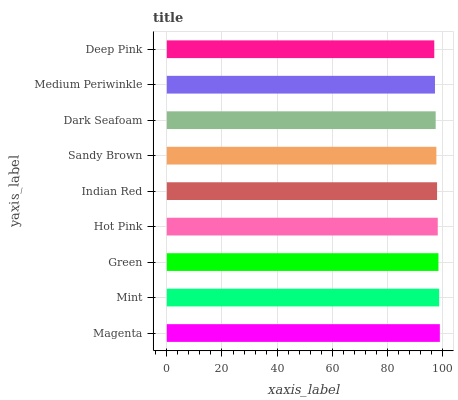Is Deep Pink the minimum?
Answer yes or no. Yes. Is Magenta the maximum?
Answer yes or no. Yes. Is Mint the minimum?
Answer yes or no. No. Is Mint the maximum?
Answer yes or no. No. Is Magenta greater than Mint?
Answer yes or no. Yes. Is Mint less than Magenta?
Answer yes or no. Yes. Is Mint greater than Magenta?
Answer yes or no. No. Is Magenta less than Mint?
Answer yes or no. No. Is Indian Red the high median?
Answer yes or no. Yes. Is Indian Red the low median?
Answer yes or no. Yes. Is Medium Periwinkle the high median?
Answer yes or no. No. Is Hot Pink the low median?
Answer yes or no. No. 